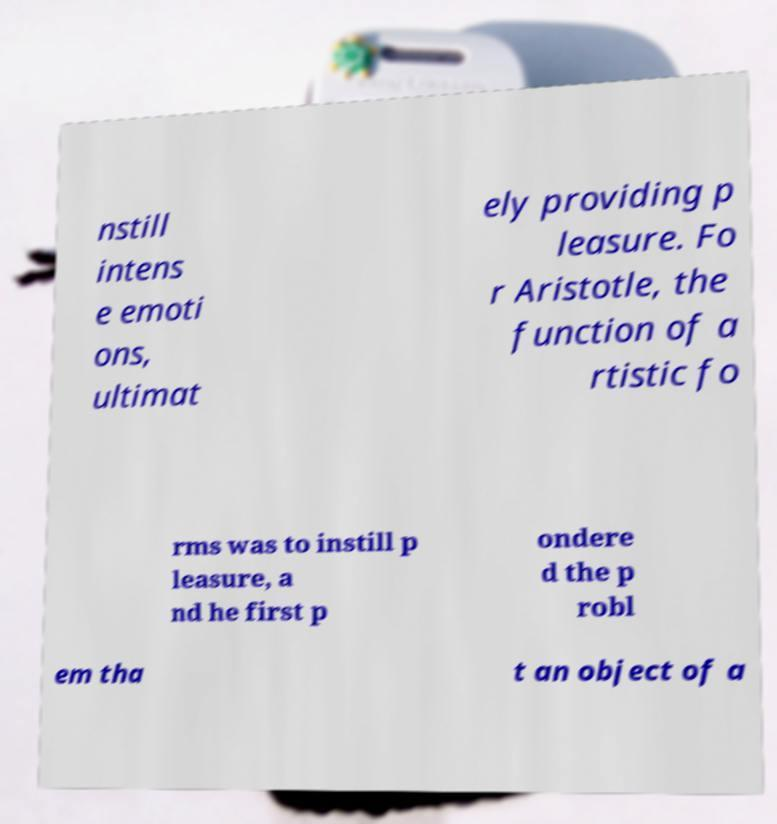Please read and relay the text visible in this image. What does it say? nstill intens e emoti ons, ultimat ely providing p leasure. Fo r Aristotle, the function of a rtistic fo rms was to instill p leasure, a nd he first p ondere d the p robl em tha t an object of a 